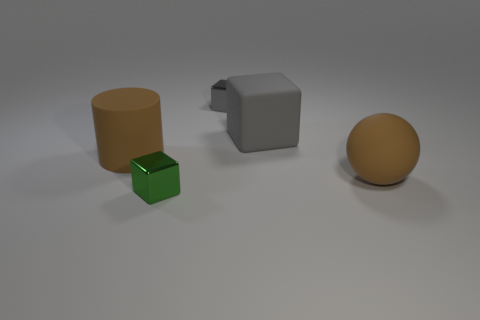Add 3 small cyan rubber cylinders. How many objects exist? 8 Subtract all cubes. How many objects are left? 2 Subtract 0 yellow cubes. How many objects are left? 5 Subtract all big blocks. Subtract all rubber cylinders. How many objects are left? 3 Add 3 brown objects. How many brown objects are left? 5 Add 1 small red metallic objects. How many small red metallic objects exist? 1 